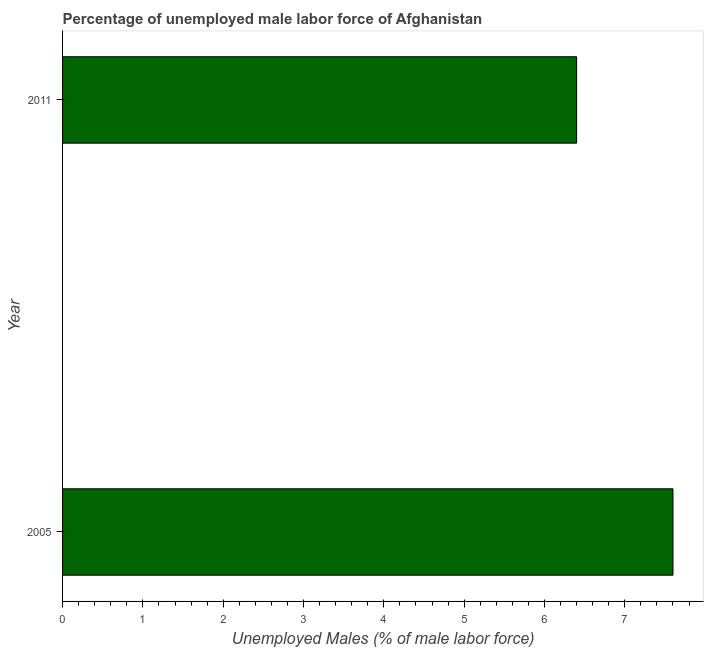Does the graph contain any zero values?
Your response must be concise. No. What is the title of the graph?
Your answer should be very brief. Percentage of unemployed male labor force of Afghanistan. What is the label or title of the X-axis?
Provide a short and direct response. Unemployed Males (% of male labor force). What is the label or title of the Y-axis?
Keep it short and to the point. Year. What is the total unemployed male labour force in 2011?
Your answer should be compact. 6.4. Across all years, what is the maximum total unemployed male labour force?
Offer a very short reply. 7.6. Across all years, what is the minimum total unemployed male labour force?
Your answer should be compact. 6.4. In which year was the total unemployed male labour force minimum?
Your response must be concise. 2011. What is the average total unemployed male labour force per year?
Keep it short and to the point. 7. What is the ratio of the total unemployed male labour force in 2005 to that in 2011?
Your answer should be compact. 1.19. How many bars are there?
Ensure brevity in your answer.  2. What is the difference between two consecutive major ticks on the X-axis?
Offer a very short reply. 1. What is the Unemployed Males (% of male labor force) in 2005?
Provide a short and direct response. 7.6. What is the Unemployed Males (% of male labor force) of 2011?
Provide a short and direct response. 6.4. What is the ratio of the Unemployed Males (% of male labor force) in 2005 to that in 2011?
Your response must be concise. 1.19. 